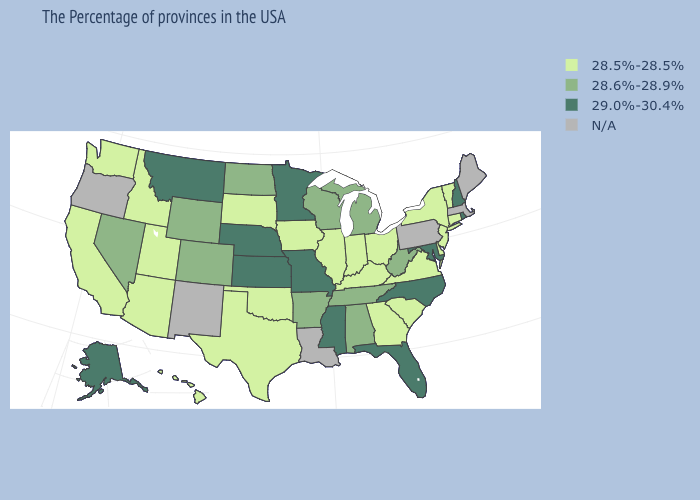What is the lowest value in the MidWest?
Give a very brief answer. 28.5%-28.5%. Does the map have missing data?
Concise answer only. Yes. Name the states that have a value in the range 28.5%-28.5%?
Give a very brief answer. Vermont, Connecticut, New York, New Jersey, Delaware, Virginia, South Carolina, Ohio, Georgia, Kentucky, Indiana, Illinois, Iowa, Oklahoma, Texas, South Dakota, Utah, Arizona, Idaho, California, Washington, Hawaii. Which states have the lowest value in the Northeast?
Concise answer only. Vermont, Connecticut, New York, New Jersey. Which states have the lowest value in the MidWest?
Quick response, please. Ohio, Indiana, Illinois, Iowa, South Dakota. Name the states that have a value in the range 28.6%-28.9%?
Give a very brief answer. West Virginia, Michigan, Alabama, Tennessee, Wisconsin, Arkansas, North Dakota, Wyoming, Colorado, Nevada. What is the highest value in states that border Indiana?
Be succinct. 28.6%-28.9%. What is the value of Arizona?
Short answer required. 28.5%-28.5%. Name the states that have a value in the range 28.5%-28.5%?
Concise answer only. Vermont, Connecticut, New York, New Jersey, Delaware, Virginia, South Carolina, Ohio, Georgia, Kentucky, Indiana, Illinois, Iowa, Oklahoma, Texas, South Dakota, Utah, Arizona, Idaho, California, Washington, Hawaii. Which states hav the highest value in the Northeast?
Short answer required. Rhode Island, New Hampshire. Among the states that border California , does Arizona have the lowest value?
Keep it brief. Yes. Name the states that have a value in the range 29.0%-30.4%?
Be succinct. Rhode Island, New Hampshire, Maryland, North Carolina, Florida, Mississippi, Missouri, Minnesota, Kansas, Nebraska, Montana, Alaska. What is the lowest value in the USA?
Be succinct. 28.5%-28.5%. Does the first symbol in the legend represent the smallest category?
Quick response, please. Yes. 